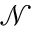<formula> <loc_0><loc_0><loc_500><loc_500>\mathcal { N }</formula> 